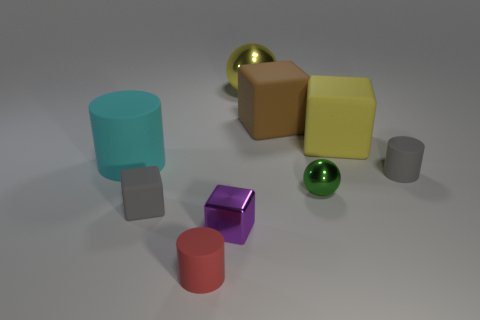There is a metallic object behind the large cylinder; is its shape the same as the small metallic object right of the large metallic object?
Make the answer very short. Yes. Are there any small cylinders in front of the yellow cube?
Offer a very short reply. Yes. There is a small rubber object that is the same shape as the large brown matte thing; what color is it?
Give a very brief answer. Gray. There is a ball in front of the tiny gray matte cylinder; what is its material?
Your response must be concise. Metal. What size is the yellow matte object that is the same shape as the big brown matte object?
Give a very brief answer. Large. What number of tiny balls are the same material as the brown thing?
Your answer should be very brief. 0. How many big metallic balls have the same color as the big cylinder?
Give a very brief answer. 0. How many objects are spheres to the left of the big brown thing or objects that are to the right of the cyan object?
Offer a very short reply. 8. Is the number of big cyan things in front of the small red object less than the number of tiny balls?
Your answer should be compact. Yes. Is there a yellow block of the same size as the yellow metal sphere?
Ensure brevity in your answer.  Yes. 